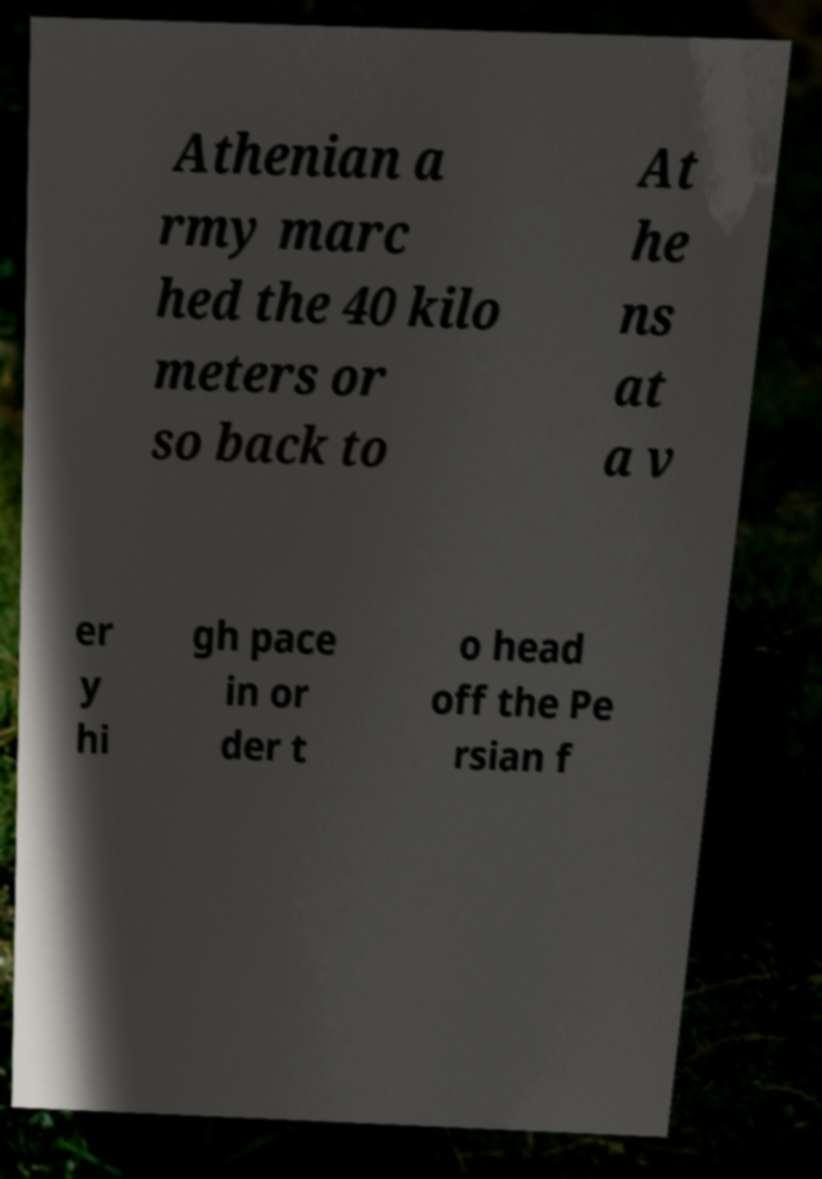There's text embedded in this image that I need extracted. Can you transcribe it verbatim? Athenian a rmy marc hed the 40 kilo meters or so back to At he ns at a v er y hi gh pace in or der t o head off the Pe rsian f 